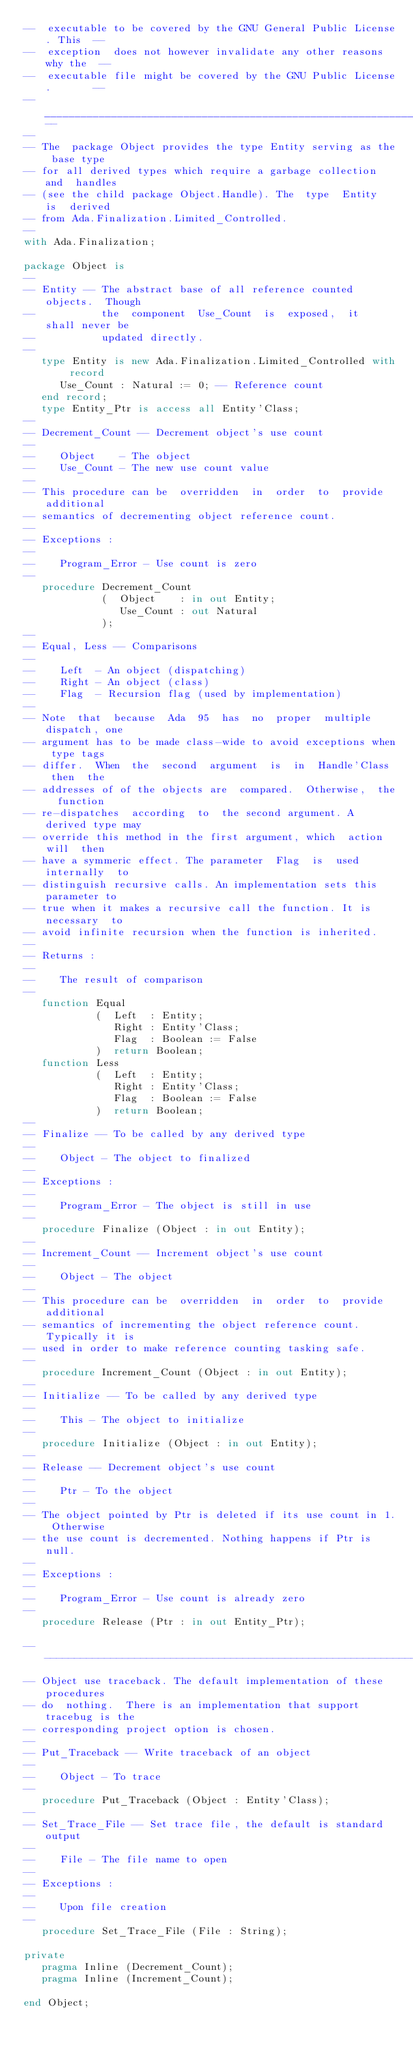Convert code to text. <code><loc_0><loc_0><loc_500><loc_500><_Ada_>--  executable to be covered by the GNU General Public License. This  --
--  exception  does not however invalidate any other reasons why the  --
--  executable file might be covered by the GNU Public License.       --
--____________________________________________________________________--
--
-- The  package Object provides the type Entity serving as the base type
-- for all derived types which require a garbage collection and  handles
-- (see the child package Object.Handle). The  type  Entity  is  derived
-- from Ada.Finalization.Limited_Controlled.
--
with Ada.Finalization;

package Object is
--
-- Entity -- The abstract base of all reference counted objects.  Though
--           the  component  Use_Count  is  exposed,  it  shall never be
--           updated directly.
--
   type Entity is new Ada.Finalization.Limited_Controlled with record
      Use_Count : Natural := 0; -- Reference count
   end record;
   type Entity_Ptr is access all Entity'Class;
--
-- Decrement_Count -- Decrement object's use count
--
--    Object    - The object
--    Use_Count - The new use count value
--
-- This procedure can be  overridden  in  order  to  provide  additional
-- semantics of decrementing object reference count.
--
-- Exceptions :
--
--    Program_Error - Use count is zero
--
   procedure Decrement_Count
             (  Object    : in out Entity;
                Use_Count : out Natural
             );
--
-- Equal, Less -- Comparisons
--
--    Left  - An object (dispatching)
--    Right - An object (class)
--    Flag  - Recursion flag (used by implementation)
--
-- Note  that  because  Ada  95  has  no  proper  multiple dispatch, one
-- argument has to be made class-wide to avoid exceptions when type tags
-- differ.  When  the  second  argument  is  in  Handle'Class  then  the
-- addresses of of the objects are  compared.  Otherwise,  the  function
-- re-dispatches  according  to  the second argument. A derived type may
-- override this method in the first argument, which  action  will  then
-- have a symmeric effect. The parameter  Flag  is  used  internally  to
-- distinguish recursive calls. An implementation sets this parameter to
-- true when it makes a recursive call the function. It is necessary  to
-- avoid infinite recursion when the function is inherited.
--
-- Returns :
--
--    The result of comparison
--
   function Equal
            (  Left  : Entity;
               Right : Entity'Class;
               Flag  : Boolean := False
            )  return Boolean;
   function Less
            (  Left  : Entity;
               Right : Entity'Class;
               Flag  : Boolean := False
            )  return Boolean;
--
-- Finalize -- To be called by any derived type
--
--    Object - The object to finalized
--
-- Exceptions :
--
--    Program_Error - The object is still in use
--
   procedure Finalize (Object : in out Entity);
--
-- Increment_Count -- Increment object's use count
--
--    Object - The object
--
-- This procedure can be  overridden  in  order  to  provide  additional
-- semantics of incrementing the object reference count. Typically it is
-- used in order to make reference counting tasking safe.
--
   procedure Increment_Count (Object : in out Entity);
--
-- Initialize -- To be called by any derived type
--
--    This - The object to initialize
--
   procedure Initialize (Object : in out Entity);
--
-- Release -- Decrement object's use count
--
--    Ptr - To the object
--
-- The object pointed by Ptr is deleted if its use count in 1. Otherwise
-- the use count is decremented. Nothing happens if Ptr is null.
--
-- Exceptions :
--
--    Program_Error - Use count is already zero
--
   procedure Release (Ptr : in out Entity_Ptr);

------------------------------------------------------------------------
-- Object use traceback. The default implementation of these  procedures
-- do  nothing.  There is an implementation that support tracebug is the
-- corresponding project option is chosen.
--
-- Put_Traceback -- Write traceback of an object
--
--    Object - To trace
--
   procedure Put_Traceback (Object : Entity'Class);
--
-- Set_Trace_File -- Set trace file, the default is standard output
--
--    File - The file name to open
--
-- Exceptions :
--
--    Upon file creation
--
   procedure Set_Trace_File (File : String);

private
   pragma Inline (Decrement_Count);
   pragma Inline (Increment_Count);

end Object;
</code> 